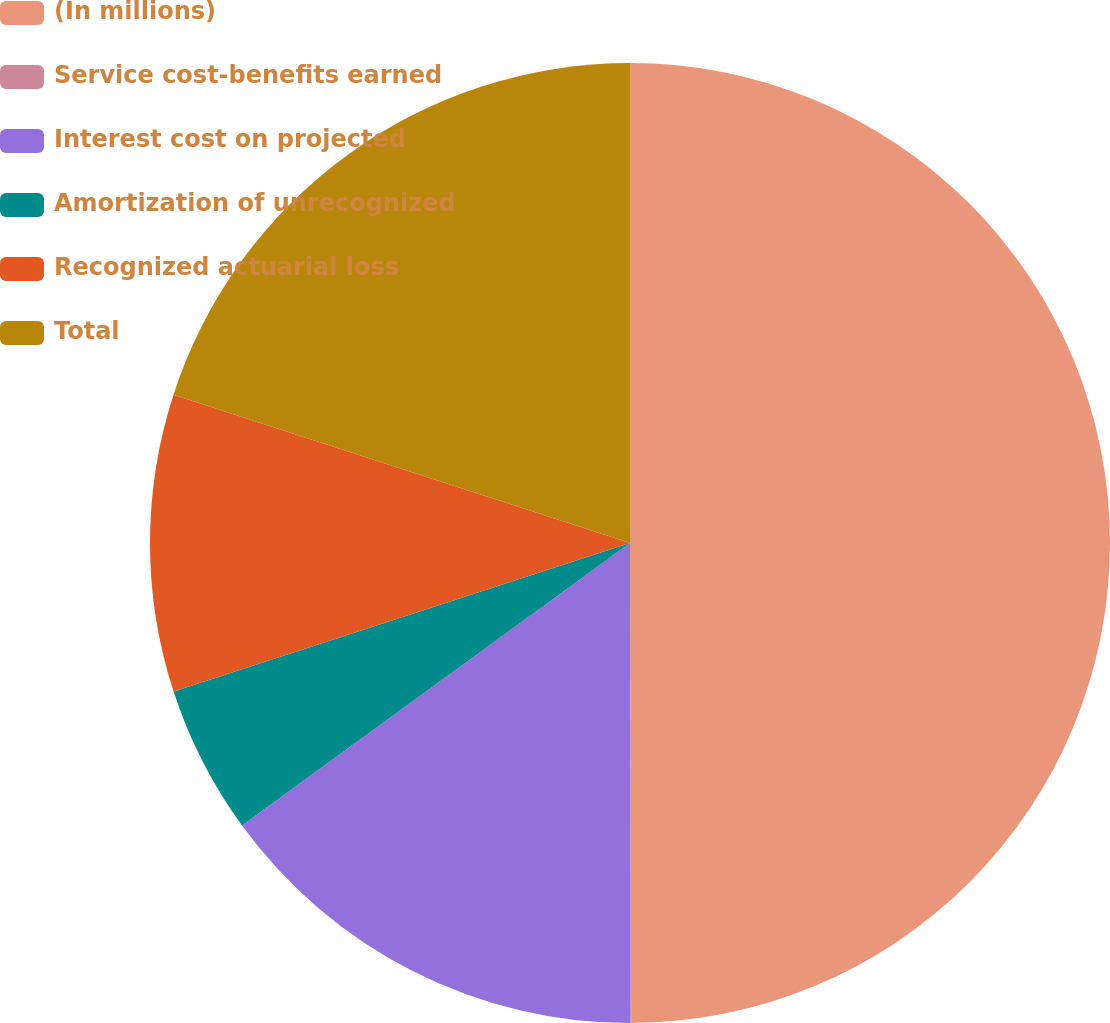<chart> <loc_0><loc_0><loc_500><loc_500><pie_chart><fcel>(In millions)<fcel>Service cost-benefits earned<fcel>Interest cost on projected<fcel>Amortization of unrecognized<fcel>Recognized actuarial loss<fcel>Total<nl><fcel>49.96%<fcel>0.02%<fcel>15.0%<fcel>5.01%<fcel>10.01%<fcel>20.0%<nl></chart> 